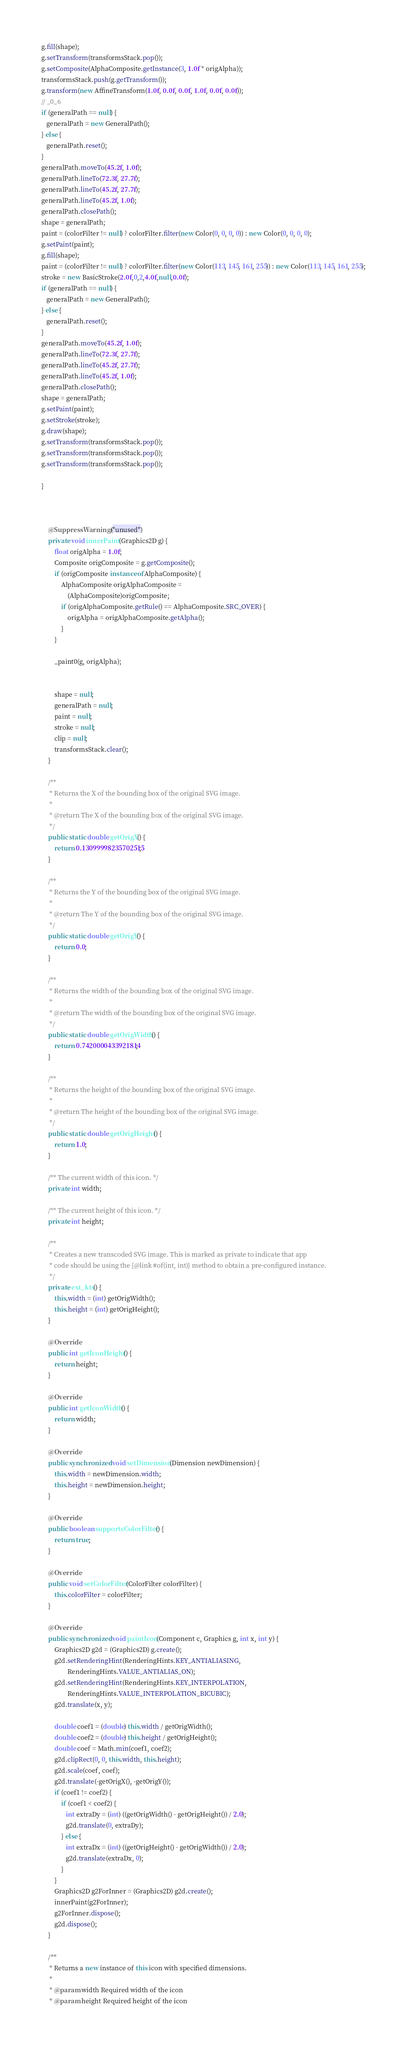Convert code to text. <code><loc_0><loc_0><loc_500><loc_500><_Java_>g.fill(shape);
g.setTransform(transformsStack.pop());
g.setComposite(AlphaComposite.getInstance(3, 1.0f * origAlpha));
transformsStack.push(g.getTransform());
g.transform(new AffineTransform(1.0f, 0.0f, 0.0f, 1.0f, 0.0f, 0.0f));
// _0_6
if (generalPath == null) {
   generalPath = new GeneralPath();
} else {
   generalPath.reset();
}
generalPath.moveTo(45.2f, 1.0f);
generalPath.lineTo(72.3f, 27.7f);
generalPath.lineTo(45.2f, 27.7f);
generalPath.lineTo(45.2f, 1.0f);
generalPath.closePath();
shape = generalPath;
paint = (colorFilter != null) ? colorFilter.filter(new Color(0, 0, 0, 0)) : new Color(0, 0, 0, 0);
g.setPaint(paint);
g.fill(shape);
paint = (colorFilter != null) ? colorFilter.filter(new Color(113, 145, 161, 255)) : new Color(113, 145, 161, 255);
stroke = new BasicStroke(2.0f,0,2,4.0f,null,0.0f);
if (generalPath == null) {
   generalPath = new GeneralPath();
} else {
   generalPath.reset();
}
generalPath.moveTo(45.2f, 1.0f);
generalPath.lineTo(72.3f, 27.7f);
generalPath.lineTo(45.2f, 27.7f);
generalPath.lineTo(45.2f, 1.0f);
generalPath.closePath();
shape = generalPath;
g.setPaint(paint);
g.setStroke(stroke);
g.draw(shape);
g.setTransform(transformsStack.pop());
g.setTransform(transformsStack.pop());
g.setTransform(transformsStack.pop());

}



    @SuppressWarnings("unused")
	private void innerPaint(Graphics2D g) {
        float origAlpha = 1.0f;
        Composite origComposite = g.getComposite();
        if (origComposite instanceof AlphaComposite) {
            AlphaComposite origAlphaComposite = 
                (AlphaComposite)origComposite;
            if (origAlphaComposite.getRule() == AlphaComposite.SRC_OVER) {
                origAlpha = origAlphaComposite.getAlpha();
            }
        }
        
	    _paint0(g, origAlpha);


	    shape = null;
	    generalPath = null;
	    paint = null;
	    stroke = null;
	    clip = null;
        transformsStack.clear();
	}

    /**
     * Returns the X of the bounding box of the original SVG image.
     * 
     * @return The X of the bounding box of the original SVG image.
     */
    public static double getOrigX() {
        return 0.13099998235702515;
    }

    /**
     * Returns the Y of the bounding box of the original SVG image.
     * 
     * @return The Y of the bounding box of the original SVG image.
     */
    public static double getOrigY() {
        return 0.0;
    }

	/**
	 * Returns the width of the bounding box of the original SVG image.
	 * 
	 * @return The width of the bounding box of the original SVG image.
	 */
	public static double getOrigWidth() {
		return 0.7420000433921814;
	}

	/**
	 * Returns the height of the bounding box of the original SVG image.
	 * 
	 * @return The height of the bounding box of the original SVG image.
	 */
	public static double getOrigHeight() {
		return 1.0;
	}

	/** The current width of this icon. */
	private int width;

    /** The current height of this icon. */
	private int height;

	/**
	 * Creates a new transcoded SVG image. This is marked as private to indicate that app
	 * code should be using the {@link #of(int, int)} method to obtain a pre-configured instance.
	 */
	private ext_kts() {
        this.width = (int) getOrigWidth();
        this.height = (int) getOrigHeight();
	}

    @Override
	public int getIconHeight() {
		return height;
	}

    @Override
	public int getIconWidth() {
		return width;
	}

	@Override
	public synchronized void setDimension(Dimension newDimension) {
		this.width = newDimension.width;
		this.height = newDimension.height;
	}

    @Override
    public boolean supportsColorFilter() {
        return true;
    }

    @Override
    public void setColorFilter(ColorFilter colorFilter) {
        this.colorFilter = colorFilter;
    }

    @Override
	public synchronized void paintIcon(Component c, Graphics g, int x, int y) {
		Graphics2D g2d = (Graphics2D) g.create();
		g2d.setRenderingHint(RenderingHints.KEY_ANTIALIASING,
				RenderingHints.VALUE_ANTIALIAS_ON);
        g2d.setRenderingHint(RenderingHints.KEY_INTERPOLATION,
                RenderingHints.VALUE_INTERPOLATION_BICUBIC);
		g2d.translate(x, y);

        double coef1 = (double) this.width / getOrigWidth();
        double coef2 = (double) this.height / getOrigHeight();
        double coef = Math.min(coef1, coef2);
        g2d.clipRect(0, 0, this.width, this.height);
        g2d.scale(coef, coef);
        g2d.translate(-getOrigX(), -getOrigY());
        if (coef1 != coef2) {
            if (coef1 < coef2) {
               int extraDy = (int) ((getOrigWidth() - getOrigHeight()) / 2.0);
               g2d.translate(0, extraDy);
            } else {
               int extraDx = (int) ((getOrigHeight() - getOrigWidth()) / 2.0);
               g2d.translate(extraDx, 0);
            }
        }
        Graphics2D g2ForInner = (Graphics2D) g2d.create();
        innerPaint(g2ForInner);
        g2ForInner.dispose();
        g2d.dispose();
	}
    
    /**
     * Returns a new instance of this icon with specified dimensions.
     *
     * @param width Required width of the icon
     * @param height Required height of the icon</code> 